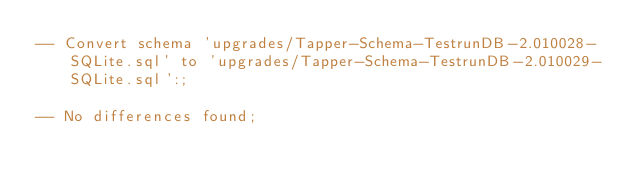<code> <loc_0><loc_0><loc_500><loc_500><_SQL_>-- Convert schema 'upgrades/Tapper-Schema-TestrunDB-2.010028-SQLite.sql' to 'upgrades/Tapper-Schema-TestrunDB-2.010029-SQLite.sql':;

-- No differences found;

</code> 